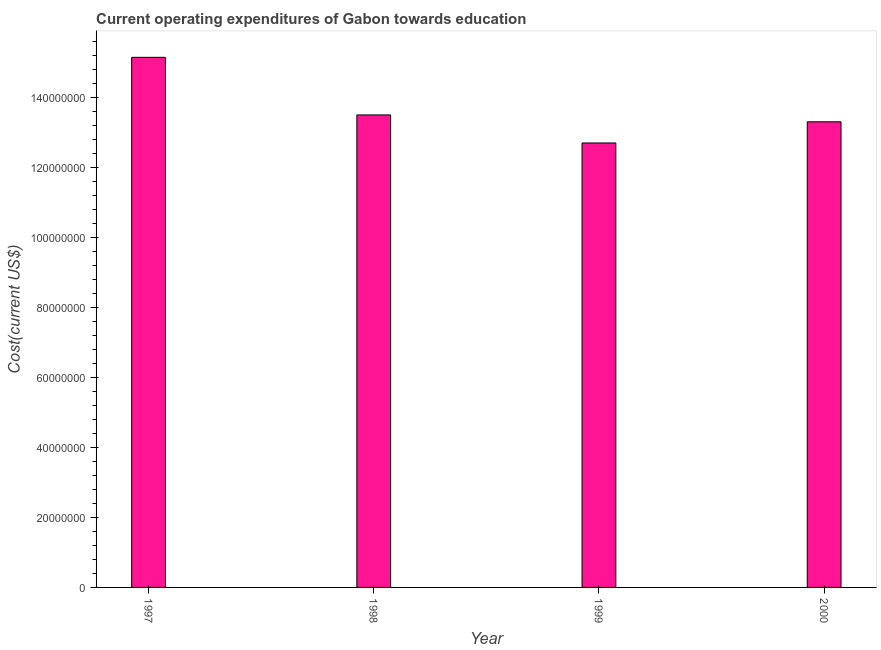Does the graph contain grids?
Ensure brevity in your answer.  No. What is the title of the graph?
Keep it short and to the point. Current operating expenditures of Gabon towards education. What is the label or title of the X-axis?
Your response must be concise. Year. What is the label or title of the Y-axis?
Your answer should be very brief. Cost(current US$). What is the education expenditure in 1998?
Ensure brevity in your answer.  1.35e+08. Across all years, what is the maximum education expenditure?
Your answer should be compact. 1.51e+08. Across all years, what is the minimum education expenditure?
Your response must be concise. 1.27e+08. What is the sum of the education expenditure?
Offer a terse response. 5.46e+08. What is the difference between the education expenditure in 1997 and 1999?
Give a very brief answer. 2.45e+07. What is the average education expenditure per year?
Your answer should be compact. 1.37e+08. What is the median education expenditure?
Your answer should be compact. 1.34e+08. In how many years, is the education expenditure greater than 16000000 US$?
Keep it short and to the point. 4. What is the ratio of the education expenditure in 1997 to that in 2000?
Your answer should be compact. 1.14. Is the education expenditure in 1998 less than that in 2000?
Your answer should be very brief. No. Is the difference between the education expenditure in 1997 and 1998 greater than the difference between any two years?
Make the answer very short. No. What is the difference between the highest and the second highest education expenditure?
Your answer should be compact. 1.65e+07. What is the difference between the highest and the lowest education expenditure?
Your answer should be compact. 2.45e+07. Are the values on the major ticks of Y-axis written in scientific E-notation?
Provide a short and direct response. No. What is the Cost(current US$) in 1997?
Give a very brief answer. 1.51e+08. What is the Cost(current US$) in 1998?
Provide a short and direct response. 1.35e+08. What is the Cost(current US$) of 1999?
Offer a terse response. 1.27e+08. What is the Cost(current US$) of 2000?
Offer a terse response. 1.33e+08. What is the difference between the Cost(current US$) in 1997 and 1998?
Offer a very short reply. 1.65e+07. What is the difference between the Cost(current US$) in 1997 and 1999?
Make the answer very short. 2.45e+07. What is the difference between the Cost(current US$) in 1997 and 2000?
Ensure brevity in your answer.  1.84e+07. What is the difference between the Cost(current US$) in 1998 and 1999?
Make the answer very short. 8.01e+06. What is the difference between the Cost(current US$) in 1998 and 2000?
Make the answer very short. 1.96e+06. What is the difference between the Cost(current US$) in 1999 and 2000?
Your response must be concise. -6.05e+06. What is the ratio of the Cost(current US$) in 1997 to that in 1998?
Make the answer very short. 1.12. What is the ratio of the Cost(current US$) in 1997 to that in 1999?
Provide a short and direct response. 1.19. What is the ratio of the Cost(current US$) in 1997 to that in 2000?
Keep it short and to the point. 1.14. What is the ratio of the Cost(current US$) in 1998 to that in 1999?
Your answer should be very brief. 1.06. What is the ratio of the Cost(current US$) in 1999 to that in 2000?
Make the answer very short. 0.95. 